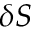Convert formula to latex. <formula><loc_0><loc_0><loc_500><loc_500>\delta S</formula> 